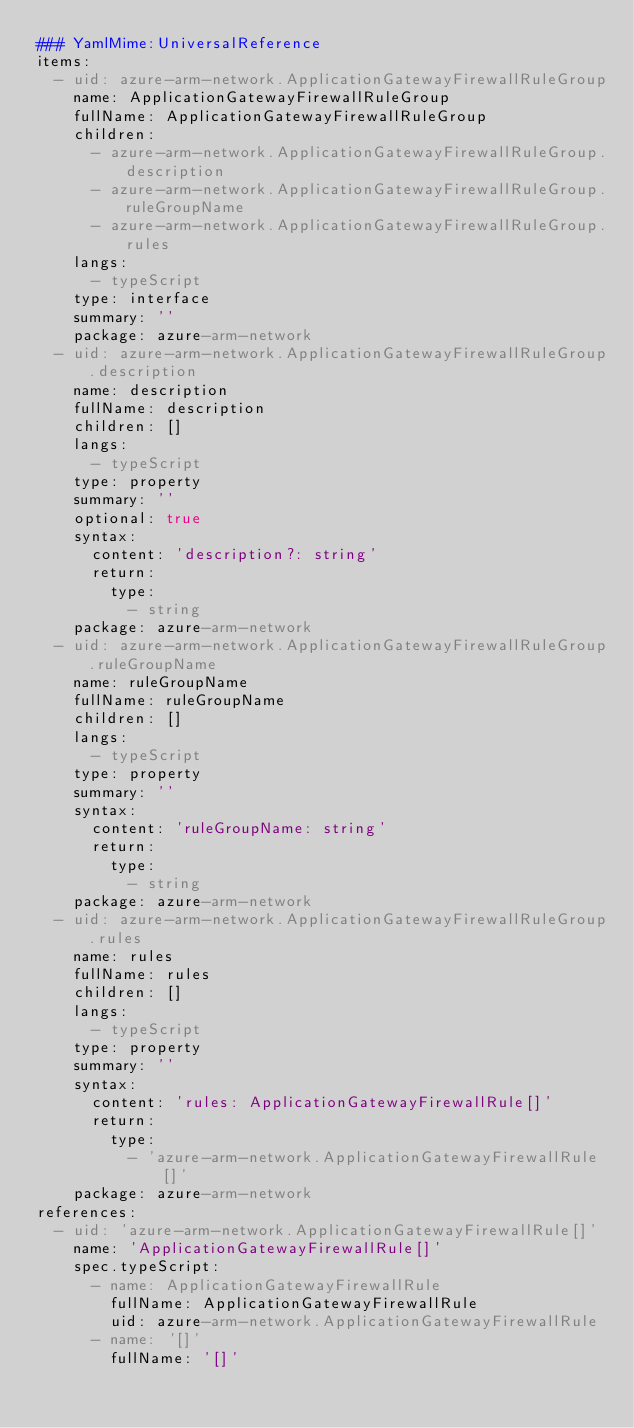Convert code to text. <code><loc_0><loc_0><loc_500><loc_500><_YAML_>### YamlMime:UniversalReference
items:
  - uid: azure-arm-network.ApplicationGatewayFirewallRuleGroup
    name: ApplicationGatewayFirewallRuleGroup
    fullName: ApplicationGatewayFirewallRuleGroup
    children:
      - azure-arm-network.ApplicationGatewayFirewallRuleGroup.description
      - azure-arm-network.ApplicationGatewayFirewallRuleGroup.ruleGroupName
      - azure-arm-network.ApplicationGatewayFirewallRuleGroup.rules
    langs:
      - typeScript
    type: interface
    summary: ''
    package: azure-arm-network
  - uid: azure-arm-network.ApplicationGatewayFirewallRuleGroup.description
    name: description
    fullName: description
    children: []
    langs:
      - typeScript
    type: property
    summary: ''
    optional: true
    syntax:
      content: 'description?: string'
      return:
        type:
          - string
    package: azure-arm-network
  - uid: azure-arm-network.ApplicationGatewayFirewallRuleGroup.ruleGroupName
    name: ruleGroupName
    fullName: ruleGroupName
    children: []
    langs:
      - typeScript
    type: property
    summary: ''
    syntax:
      content: 'ruleGroupName: string'
      return:
        type:
          - string
    package: azure-arm-network
  - uid: azure-arm-network.ApplicationGatewayFirewallRuleGroup.rules
    name: rules
    fullName: rules
    children: []
    langs:
      - typeScript
    type: property
    summary: ''
    syntax:
      content: 'rules: ApplicationGatewayFirewallRule[]'
      return:
        type:
          - 'azure-arm-network.ApplicationGatewayFirewallRule[]'
    package: azure-arm-network
references:
  - uid: 'azure-arm-network.ApplicationGatewayFirewallRule[]'
    name: 'ApplicationGatewayFirewallRule[]'
    spec.typeScript:
      - name: ApplicationGatewayFirewallRule
        fullName: ApplicationGatewayFirewallRule
        uid: azure-arm-network.ApplicationGatewayFirewallRule
      - name: '[]'
        fullName: '[]'
</code> 